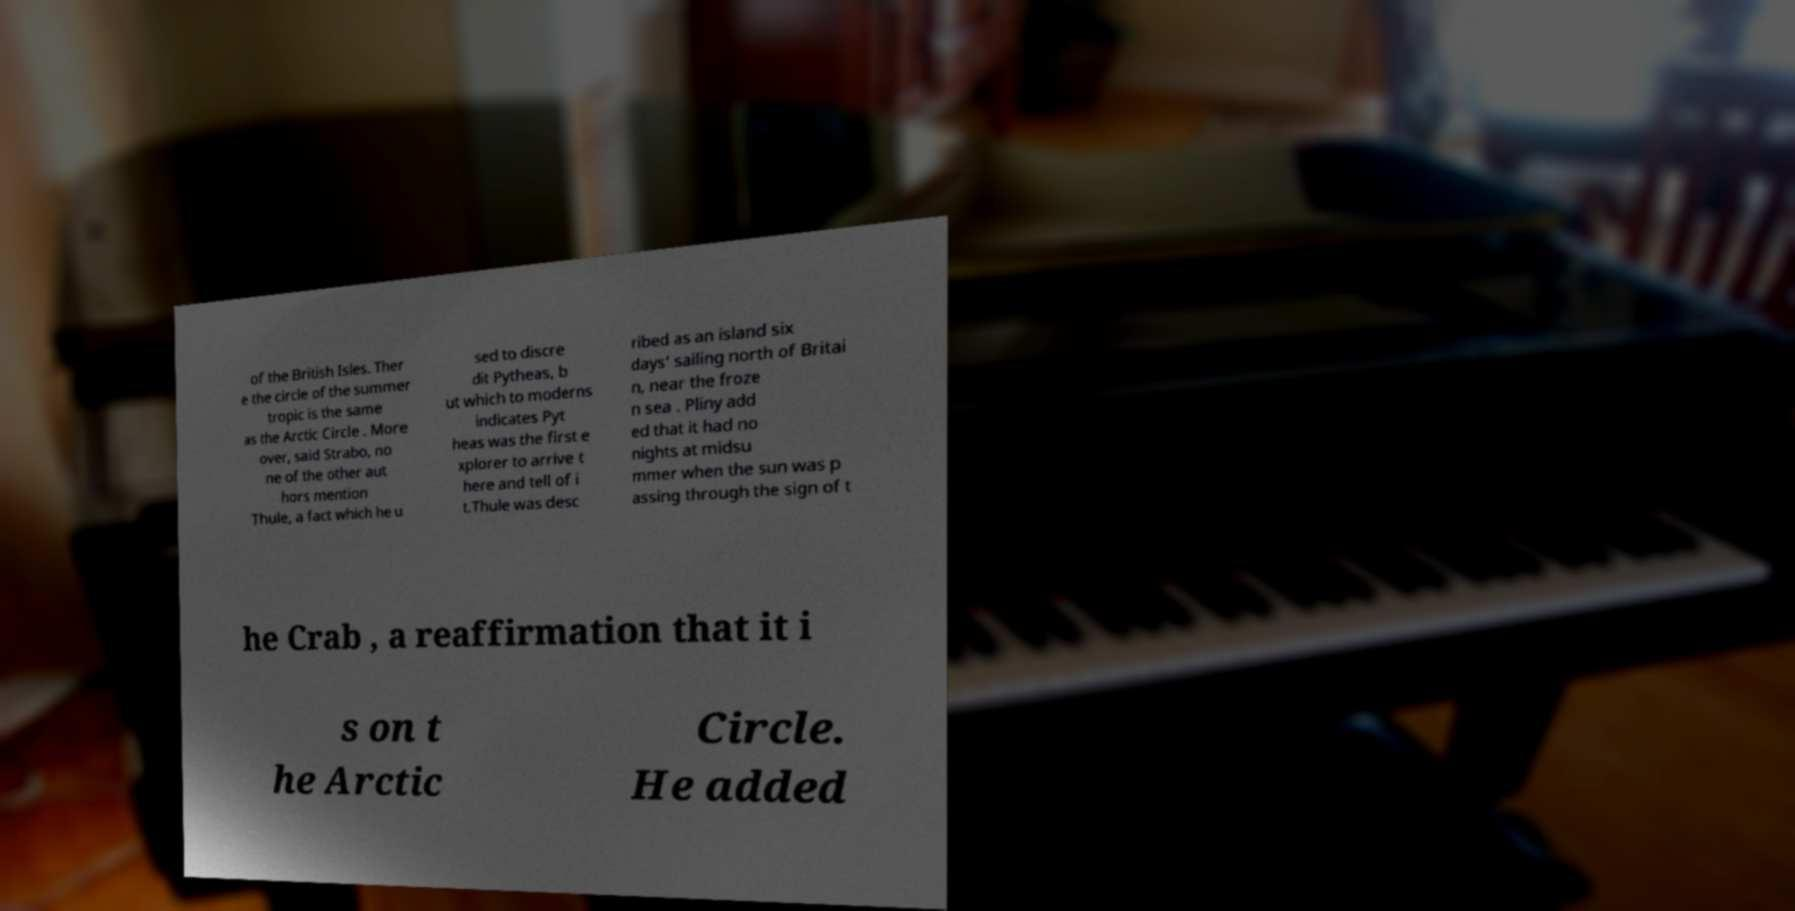I need the written content from this picture converted into text. Can you do that? of the British Isles. Ther e the circle of the summer tropic is the same as the Arctic Circle . More over, said Strabo, no ne of the other aut hors mention Thule, a fact which he u sed to discre dit Pytheas, b ut which to moderns indicates Pyt heas was the first e xplorer to arrive t here and tell of i t.Thule was desc ribed as an island six days' sailing north of Britai n, near the froze n sea . Pliny add ed that it had no nights at midsu mmer when the sun was p assing through the sign of t he Crab , a reaffirmation that it i s on t he Arctic Circle. He added 